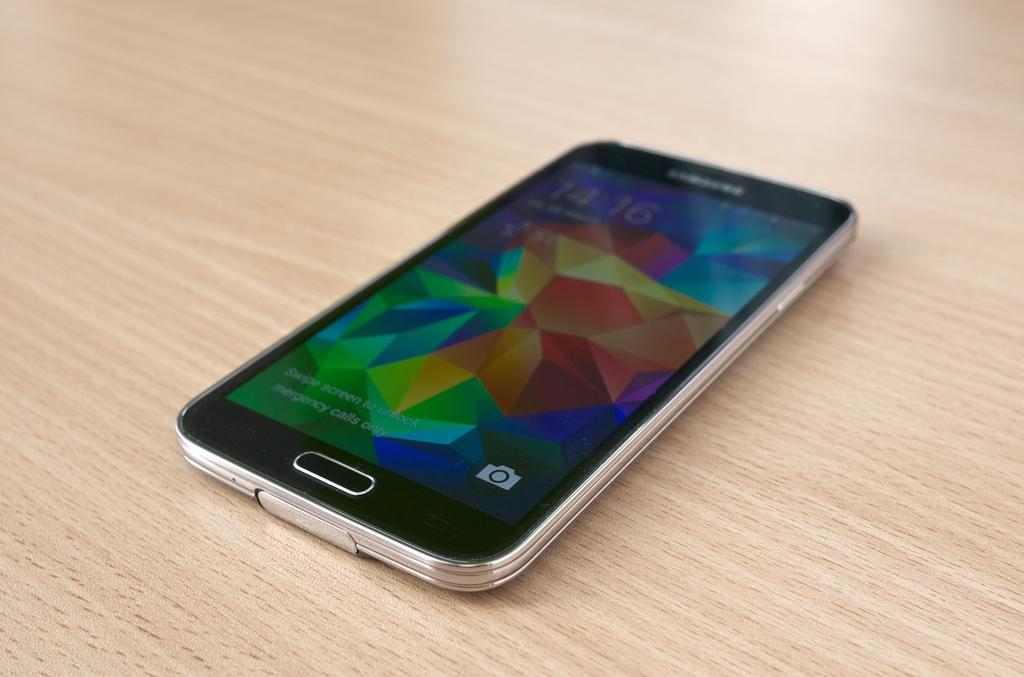Provide a one-sentence caption for the provided image. A Samsung phone is sitting on a wooden table. 